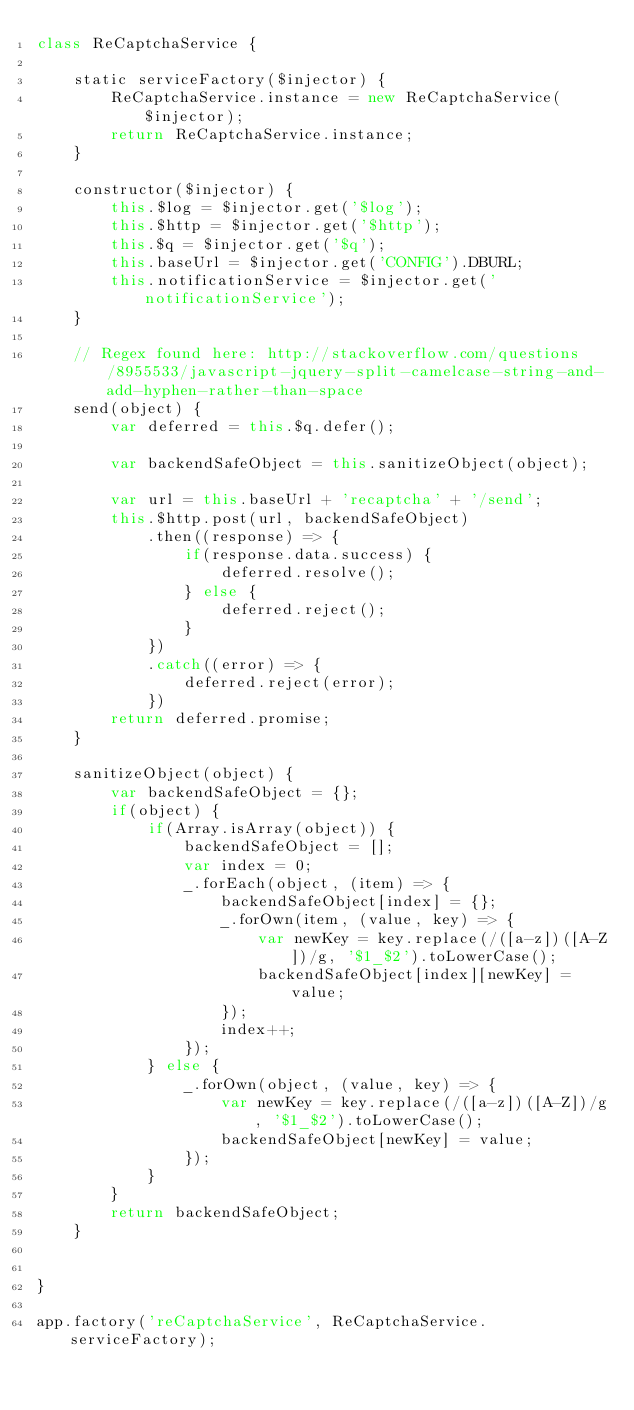Convert code to text. <code><loc_0><loc_0><loc_500><loc_500><_JavaScript_>class ReCaptchaService {

    static serviceFactory($injector) {
        ReCaptchaService.instance = new ReCaptchaService($injector);
        return ReCaptchaService.instance;
    }

    constructor($injector) {
        this.$log = $injector.get('$log');
        this.$http = $injector.get('$http');
        this.$q = $injector.get('$q');
        this.baseUrl = $injector.get('CONFIG').DBURL;
        this.notificationService = $injector.get('notificationService');
    }

    // Regex found here: http://stackoverflow.com/questions/8955533/javascript-jquery-split-camelcase-string-and-add-hyphen-rather-than-space
    send(object) {
        var deferred = this.$q.defer();

        var backendSafeObject = this.sanitizeObject(object);

        var url = this.baseUrl + 'recaptcha' + '/send';
        this.$http.post(url, backendSafeObject)
            .then((response) => {
                if(response.data.success) {
                    deferred.resolve();
                } else {
                    deferred.reject();
                }
            })
            .catch((error) => {
                deferred.reject(error);
            })
        return deferred.promise;
    }

    sanitizeObject(object) {
        var backendSafeObject = {};
        if(object) {
            if(Array.isArray(object)) {
                backendSafeObject = [];
                var index = 0;
                _.forEach(object, (item) => {
                    backendSafeObject[index] = {};
                    _.forOwn(item, (value, key) => {
                        var newKey = key.replace(/([a-z])([A-Z])/g, '$1_$2').toLowerCase();
                        backendSafeObject[index][newKey] = value;
                    });
                    index++;
                });
            } else {
                _.forOwn(object, (value, key) => {
                    var newKey = key.replace(/([a-z])([A-Z])/g, '$1_$2').toLowerCase();
                    backendSafeObject[newKey] = value;
                });
            }
        }
        return backendSafeObject;
    }


}

app.factory('reCaptchaService', ReCaptchaService.serviceFactory);</code> 